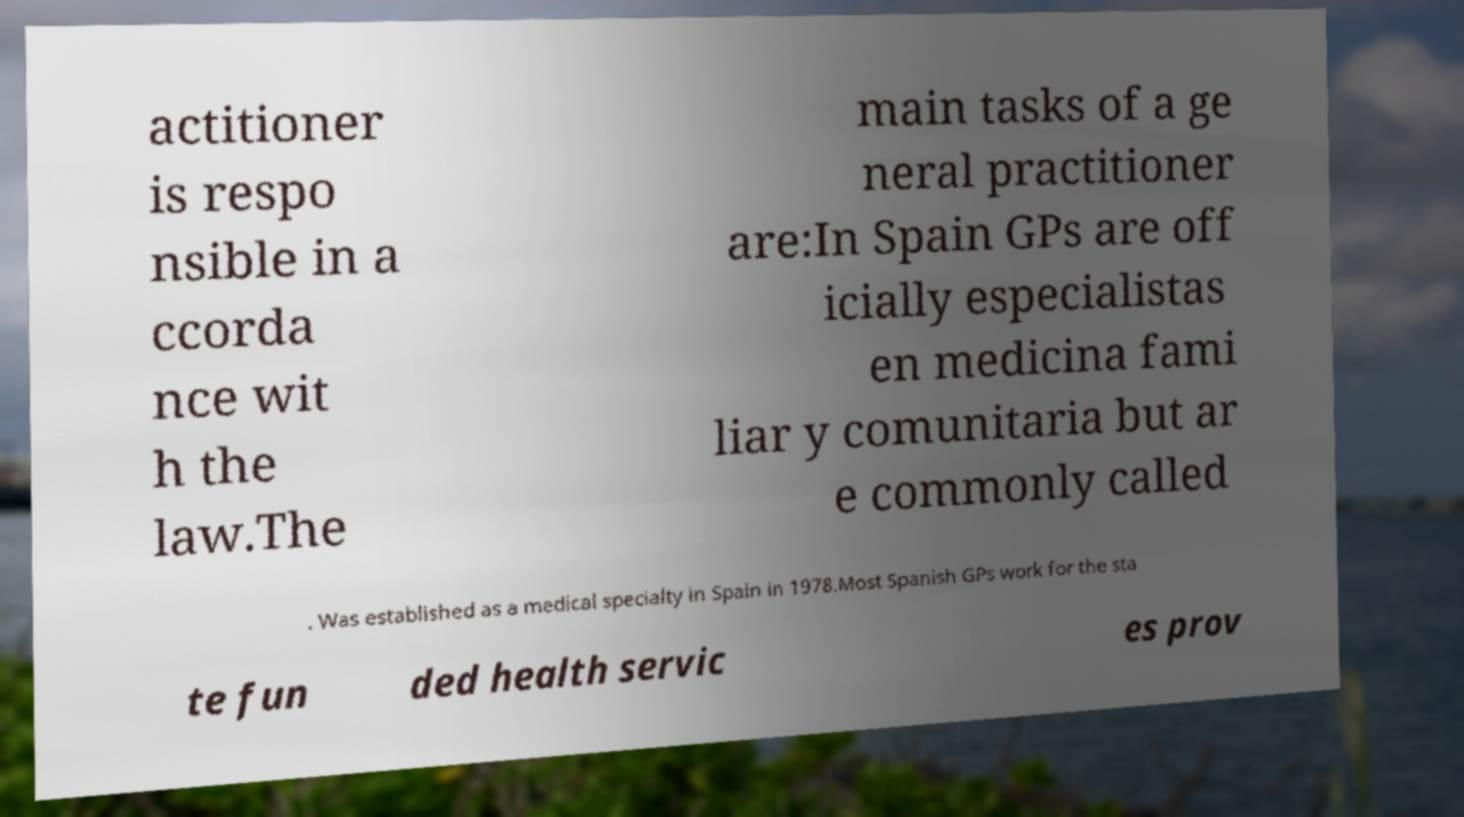Could you extract and type out the text from this image? actitioner is respo nsible in a ccorda nce wit h the law.The main tasks of a ge neral practitioner are:In Spain GPs are off icially especialistas en medicina fami liar y comunitaria but ar e commonly called . Was established as a medical specialty in Spain in 1978.Most Spanish GPs work for the sta te fun ded health servic es prov 